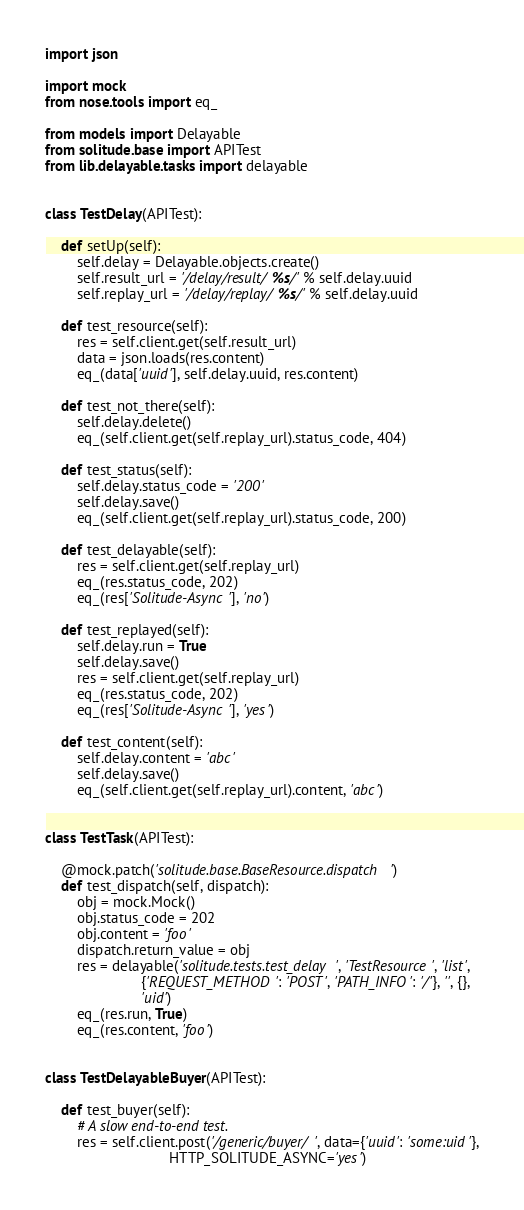<code> <loc_0><loc_0><loc_500><loc_500><_Python_>import json

import mock
from nose.tools import eq_

from models import Delayable
from solitude.base import APITest
from lib.delayable.tasks import delayable


class TestDelay(APITest):

    def setUp(self):
        self.delay = Delayable.objects.create()
        self.result_url = '/delay/result/%s/' % self.delay.uuid
        self.replay_url = '/delay/replay/%s/' % self.delay.uuid

    def test_resource(self):
        res = self.client.get(self.result_url)
        data = json.loads(res.content)
        eq_(data['uuid'], self.delay.uuid, res.content)

    def test_not_there(self):
        self.delay.delete()
        eq_(self.client.get(self.replay_url).status_code, 404)

    def test_status(self):
        self.delay.status_code = '200'
        self.delay.save()
        eq_(self.client.get(self.replay_url).status_code, 200)

    def test_delayable(self):
        res = self.client.get(self.replay_url)
        eq_(res.status_code, 202)
        eq_(res['Solitude-Async'], 'no')

    def test_replayed(self):
        self.delay.run = True
        self.delay.save()
        res = self.client.get(self.replay_url)
        eq_(res.status_code, 202)
        eq_(res['Solitude-Async'], 'yes')

    def test_content(self):
        self.delay.content = 'abc'
        self.delay.save()
        eq_(self.client.get(self.replay_url).content, 'abc')


class TestTask(APITest):

    @mock.patch('solitude.base.BaseResource.dispatch')
    def test_dispatch(self, dispatch):
        obj = mock.Mock()
        obj.status_code = 202
        obj.content = 'foo'
        dispatch.return_value = obj
        res = delayable('solitude.tests.test_delay', 'TestResource', 'list',
                        {'REQUEST_METHOD': 'POST', 'PATH_INFO': '/'}, '', {},
                        'uid')
        eq_(res.run, True)
        eq_(res.content, 'foo')


class TestDelayableBuyer(APITest):

    def test_buyer(self):
        # A slow end-to-end test.
        res = self.client.post('/generic/buyer/', data={'uuid': 'some:uid'},
                               HTTP_SOLITUDE_ASYNC='yes')</code> 